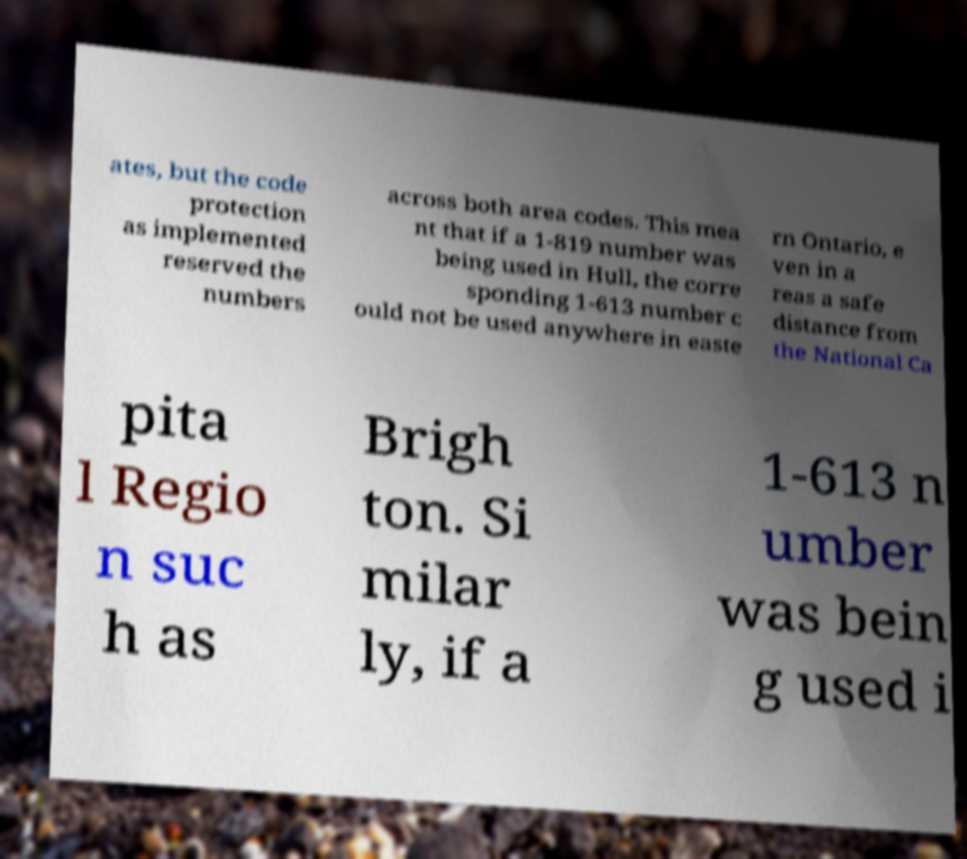Could you extract and type out the text from this image? ates, but the code protection as implemented reserved the numbers across both area codes. This mea nt that if a 1-819 number was being used in Hull, the corre sponding 1-613 number c ould not be used anywhere in easte rn Ontario, e ven in a reas a safe distance from the National Ca pita l Regio n suc h as Brigh ton. Si milar ly, if a 1-613 n umber was bein g used i 